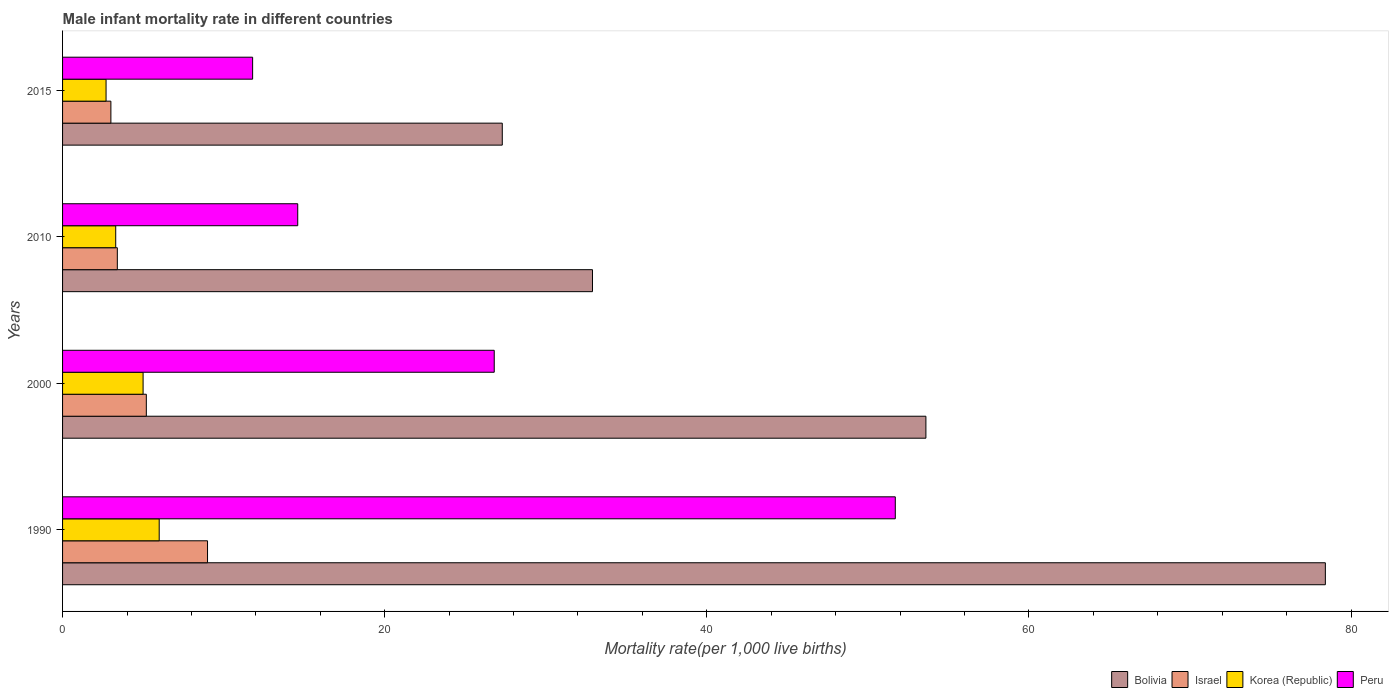How many groups of bars are there?
Keep it short and to the point. 4. Are the number of bars per tick equal to the number of legend labels?
Ensure brevity in your answer.  Yes. Are the number of bars on each tick of the Y-axis equal?
Give a very brief answer. Yes. How many bars are there on the 4th tick from the bottom?
Offer a terse response. 4. What is the male infant mortality rate in Peru in 1990?
Keep it short and to the point. 51.7. Across all years, what is the maximum male infant mortality rate in Bolivia?
Your answer should be very brief. 78.4. In which year was the male infant mortality rate in Israel maximum?
Your response must be concise. 1990. In which year was the male infant mortality rate in Israel minimum?
Make the answer very short. 2015. What is the total male infant mortality rate in Israel in the graph?
Make the answer very short. 20.6. What is the difference between the male infant mortality rate in Israel in 2000 and that in 2010?
Keep it short and to the point. 1.8. What is the difference between the male infant mortality rate in Korea (Republic) in 2010 and the male infant mortality rate in Israel in 2000?
Give a very brief answer. -1.9. What is the average male infant mortality rate in Korea (Republic) per year?
Make the answer very short. 4.25. In the year 1990, what is the difference between the male infant mortality rate in Korea (Republic) and male infant mortality rate in Peru?
Your response must be concise. -45.7. In how many years, is the male infant mortality rate in Israel greater than 32 ?
Make the answer very short. 0. What is the ratio of the male infant mortality rate in Peru in 2000 to that in 2010?
Provide a succinct answer. 1.84. Is the male infant mortality rate in Korea (Republic) in 1990 less than that in 2010?
Provide a succinct answer. No. Is the difference between the male infant mortality rate in Korea (Republic) in 1990 and 2015 greater than the difference between the male infant mortality rate in Peru in 1990 and 2015?
Provide a succinct answer. No. What is the difference between the highest and the second highest male infant mortality rate in Bolivia?
Ensure brevity in your answer.  24.8. In how many years, is the male infant mortality rate in Bolivia greater than the average male infant mortality rate in Bolivia taken over all years?
Provide a short and direct response. 2. Is the sum of the male infant mortality rate in Peru in 2000 and 2015 greater than the maximum male infant mortality rate in Bolivia across all years?
Offer a very short reply. No. What does the 3rd bar from the bottom in 2015 represents?
Give a very brief answer. Korea (Republic). Is it the case that in every year, the sum of the male infant mortality rate in Korea (Republic) and male infant mortality rate in Israel is greater than the male infant mortality rate in Bolivia?
Provide a succinct answer. No. Are all the bars in the graph horizontal?
Offer a very short reply. Yes. Does the graph contain any zero values?
Keep it short and to the point. No. Where does the legend appear in the graph?
Offer a terse response. Bottom right. What is the title of the graph?
Make the answer very short. Male infant mortality rate in different countries. What is the label or title of the X-axis?
Keep it short and to the point. Mortality rate(per 1,0 live births). What is the label or title of the Y-axis?
Make the answer very short. Years. What is the Mortality rate(per 1,000 live births) of Bolivia in 1990?
Provide a succinct answer. 78.4. What is the Mortality rate(per 1,000 live births) of Peru in 1990?
Keep it short and to the point. 51.7. What is the Mortality rate(per 1,000 live births) in Bolivia in 2000?
Your answer should be compact. 53.6. What is the Mortality rate(per 1,000 live births) in Korea (Republic) in 2000?
Offer a terse response. 5. What is the Mortality rate(per 1,000 live births) in Peru in 2000?
Your response must be concise. 26.8. What is the Mortality rate(per 1,000 live births) of Bolivia in 2010?
Provide a short and direct response. 32.9. What is the Mortality rate(per 1,000 live births) of Israel in 2010?
Provide a short and direct response. 3.4. What is the Mortality rate(per 1,000 live births) of Peru in 2010?
Your response must be concise. 14.6. What is the Mortality rate(per 1,000 live births) in Bolivia in 2015?
Your answer should be very brief. 27.3. What is the Mortality rate(per 1,000 live births) in Israel in 2015?
Your answer should be very brief. 3. What is the Mortality rate(per 1,000 live births) in Peru in 2015?
Ensure brevity in your answer.  11.8. Across all years, what is the maximum Mortality rate(per 1,000 live births) in Bolivia?
Provide a short and direct response. 78.4. Across all years, what is the maximum Mortality rate(per 1,000 live births) in Korea (Republic)?
Provide a succinct answer. 6. Across all years, what is the maximum Mortality rate(per 1,000 live births) in Peru?
Your response must be concise. 51.7. Across all years, what is the minimum Mortality rate(per 1,000 live births) in Bolivia?
Offer a terse response. 27.3. Across all years, what is the minimum Mortality rate(per 1,000 live births) of Israel?
Provide a succinct answer. 3. Across all years, what is the minimum Mortality rate(per 1,000 live births) in Korea (Republic)?
Your response must be concise. 2.7. What is the total Mortality rate(per 1,000 live births) of Bolivia in the graph?
Ensure brevity in your answer.  192.2. What is the total Mortality rate(per 1,000 live births) of Israel in the graph?
Your response must be concise. 20.6. What is the total Mortality rate(per 1,000 live births) of Peru in the graph?
Your answer should be very brief. 104.9. What is the difference between the Mortality rate(per 1,000 live births) in Bolivia in 1990 and that in 2000?
Your answer should be compact. 24.8. What is the difference between the Mortality rate(per 1,000 live births) of Peru in 1990 and that in 2000?
Your answer should be very brief. 24.9. What is the difference between the Mortality rate(per 1,000 live births) of Bolivia in 1990 and that in 2010?
Ensure brevity in your answer.  45.5. What is the difference between the Mortality rate(per 1,000 live births) in Israel in 1990 and that in 2010?
Offer a very short reply. 5.6. What is the difference between the Mortality rate(per 1,000 live births) of Peru in 1990 and that in 2010?
Offer a very short reply. 37.1. What is the difference between the Mortality rate(per 1,000 live births) in Bolivia in 1990 and that in 2015?
Provide a short and direct response. 51.1. What is the difference between the Mortality rate(per 1,000 live births) of Peru in 1990 and that in 2015?
Provide a short and direct response. 39.9. What is the difference between the Mortality rate(per 1,000 live births) of Bolivia in 2000 and that in 2010?
Keep it short and to the point. 20.7. What is the difference between the Mortality rate(per 1,000 live births) of Korea (Republic) in 2000 and that in 2010?
Provide a short and direct response. 1.7. What is the difference between the Mortality rate(per 1,000 live births) of Peru in 2000 and that in 2010?
Give a very brief answer. 12.2. What is the difference between the Mortality rate(per 1,000 live births) of Bolivia in 2000 and that in 2015?
Offer a very short reply. 26.3. What is the difference between the Mortality rate(per 1,000 live births) in Israel in 2000 and that in 2015?
Your answer should be very brief. 2.2. What is the difference between the Mortality rate(per 1,000 live births) of Korea (Republic) in 2000 and that in 2015?
Make the answer very short. 2.3. What is the difference between the Mortality rate(per 1,000 live births) of Peru in 2000 and that in 2015?
Ensure brevity in your answer.  15. What is the difference between the Mortality rate(per 1,000 live births) of Israel in 2010 and that in 2015?
Your response must be concise. 0.4. What is the difference between the Mortality rate(per 1,000 live births) in Peru in 2010 and that in 2015?
Offer a very short reply. 2.8. What is the difference between the Mortality rate(per 1,000 live births) of Bolivia in 1990 and the Mortality rate(per 1,000 live births) of Israel in 2000?
Provide a short and direct response. 73.2. What is the difference between the Mortality rate(per 1,000 live births) in Bolivia in 1990 and the Mortality rate(per 1,000 live births) in Korea (Republic) in 2000?
Your answer should be compact. 73.4. What is the difference between the Mortality rate(per 1,000 live births) of Bolivia in 1990 and the Mortality rate(per 1,000 live births) of Peru in 2000?
Offer a terse response. 51.6. What is the difference between the Mortality rate(per 1,000 live births) of Israel in 1990 and the Mortality rate(per 1,000 live births) of Korea (Republic) in 2000?
Make the answer very short. 4. What is the difference between the Mortality rate(per 1,000 live births) of Israel in 1990 and the Mortality rate(per 1,000 live births) of Peru in 2000?
Your response must be concise. -17.8. What is the difference between the Mortality rate(per 1,000 live births) in Korea (Republic) in 1990 and the Mortality rate(per 1,000 live births) in Peru in 2000?
Keep it short and to the point. -20.8. What is the difference between the Mortality rate(per 1,000 live births) of Bolivia in 1990 and the Mortality rate(per 1,000 live births) of Korea (Republic) in 2010?
Offer a terse response. 75.1. What is the difference between the Mortality rate(per 1,000 live births) of Bolivia in 1990 and the Mortality rate(per 1,000 live births) of Peru in 2010?
Your response must be concise. 63.8. What is the difference between the Mortality rate(per 1,000 live births) of Israel in 1990 and the Mortality rate(per 1,000 live births) of Korea (Republic) in 2010?
Offer a very short reply. 5.7. What is the difference between the Mortality rate(per 1,000 live births) in Israel in 1990 and the Mortality rate(per 1,000 live births) in Peru in 2010?
Keep it short and to the point. -5.6. What is the difference between the Mortality rate(per 1,000 live births) in Bolivia in 1990 and the Mortality rate(per 1,000 live births) in Israel in 2015?
Keep it short and to the point. 75.4. What is the difference between the Mortality rate(per 1,000 live births) of Bolivia in 1990 and the Mortality rate(per 1,000 live births) of Korea (Republic) in 2015?
Provide a succinct answer. 75.7. What is the difference between the Mortality rate(per 1,000 live births) in Bolivia in 1990 and the Mortality rate(per 1,000 live births) in Peru in 2015?
Provide a succinct answer. 66.6. What is the difference between the Mortality rate(per 1,000 live births) in Israel in 1990 and the Mortality rate(per 1,000 live births) in Korea (Republic) in 2015?
Give a very brief answer. 6.3. What is the difference between the Mortality rate(per 1,000 live births) in Korea (Republic) in 1990 and the Mortality rate(per 1,000 live births) in Peru in 2015?
Give a very brief answer. -5.8. What is the difference between the Mortality rate(per 1,000 live births) in Bolivia in 2000 and the Mortality rate(per 1,000 live births) in Israel in 2010?
Offer a terse response. 50.2. What is the difference between the Mortality rate(per 1,000 live births) in Bolivia in 2000 and the Mortality rate(per 1,000 live births) in Korea (Republic) in 2010?
Give a very brief answer. 50.3. What is the difference between the Mortality rate(per 1,000 live births) in Bolivia in 2000 and the Mortality rate(per 1,000 live births) in Peru in 2010?
Keep it short and to the point. 39. What is the difference between the Mortality rate(per 1,000 live births) of Israel in 2000 and the Mortality rate(per 1,000 live births) of Korea (Republic) in 2010?
Your response must be concise. 1.9. What is the difference between the Mortality rate(per 1,000 live births) of Israel in 2000 and the Mortality rate(per 1,000 live births) of Peru in 2010?
Make the answer very short. -9.4. What is the difference between the Mortality rate(per 1,000 live births) in Bolivia in 2000 and the Mortality rate(per 1,000 live births) in Israel in 2015?
Make the answer very short. 50.6. What is the difference between the Mortality rate(per 1,000 live births) in Bolivia in 2000 and the Mortality rate(per 1,000 live births) in Korea (Republic) in 2015?
Your answer should be very brief. 50.9. What is the difference between the Mortality rate(per 1,000 live births) in Bolivia in 2000 and the Mortality rate(per 1,000 live births) in Peru in 2015?
Your answer should be very brief. 41.8. What is the difference between the Mortality rate(per 1,000 live births) in Israel in 2000 and the Mortality rate(per 1,000 live births) in Korea (Republic) in 2015?
Give a very brief answer. 2.5. What is the difference between the Mortality rate(per 1,000 live births) of Bolivia in 2010 and the Mortality rate(per 1,000 live births) of Israel in 2015?
Give a very brief answer. 29.9. What is the difference between the Mortality rate(per 1,000 live births) of Bolivia in 2010 and the Mortality rate(per 1,000 live births) of Korea (Republic) in 2015?
Provide a short and direct response. 30.2. What is the difference between the Mortality rate(per 1,000 live births) of Bolivia in 2010 and the Mortality rate(per 1,000 live births) of Peru in 2015?
Your answer should be very brief. 21.1. What is the difference between the Mortality rate(per 1,000 live births) of Israel in 2010 and the Mortality rate(per 1,000 live births) of Korea (Republic) in 2015?
Provide a succinct answer. 0.7. What is the average Mortality rate(per 1,000 live births) of Bolivia per year?
Offer a very short reply. 48.05. What is the average Mortality rate(per 1,000 live births) in Israel per year?
Your response must be concise. 5.15. What is the average Mortality rate(per 1,000 live births) of Korea (Republic) per year?
Offer a terse response. 4.25. What is the average Mortality rate(per 1,000 live births) of Peru per year?
Provide a succinct answer. 26.23. In the year 1990, what is the difference between the Mortality rate(per 1,000 live births) of Bolivia and Mortality rate(per 1,000 live births) of Israel?
Give a very brief answer. 69.4. In the year 1990, what is the difference between the Mortality rate(per 1,000 live births) in Bolivia and Mortality rate(per 1,000 live births) in Korea (Republic)?
Keep it short and to the point. 72.4. In the year 1990, what is the difference between the Mortality rate(per 1,000 live births) of Bolivia and Mortality rate(per 1,000 live births) of Peru?
Give a very brief answer. 26.7. In the year 1990, what is the difference between the Mortality rate(per 1,000 live births) in Israel and Mortality rate(per 1,000 live births) in Korea (Republic)?
Keep it short and to the point. 3. In the year 1990, what is the difference between the Mortality rate(per 1,000 live births) of Israel and Mortality rate(per 1,000 live births) of Peru?
Provide a succinct answer. -42.7. In the year 1990, what is the difference between the Mortality rate(per 1,000 live births) of Korea (Republic) and Mortality rate(per 1,000 live births) of Peru?
Your answer should be very brief. -45.7. In the year 2000, what is the difference between the Mortality rate(per 1,000 live births) in Bolivia and Mortality rate(per 1,000 live births) in Israel?
Your answer should be very brief. 48.4. In the year 2000, what is the difference between the Mortality rate(per 1,000 live births) in Bolivia and Mortality rate(per 1,000 live births) in Korea (Republic)?
Provide a short and direct response. 48.6. In the year 2000, what is the difference between the Mortality rate(per 1,000 live births) of Bolivia and Mortality rate(per 1,000 live births) of Peru?
Your response must be concise. 26.8. In the year 2000, what is the difference between the Mortality rate(per 1,000 live births) of Israel and Mortality rate(per 1,000 live births) of Peru?
Provide a short and direct response. -21.6. In the year 2000, what is the difference between the Mortality rate(per 1,000 live births) of Korea (Republic) and Mortality rate(per 1,000 live births) of Peru?
Keep it short and to the point. -21.8. In the year 2010, what is the difference between the Mortality rate(per 1,000 live births) of Bolivia and Mortality rate(per 1,000 live births) of Israel?
Offer a terse response. 29.5. In the year 2010, what is the difference between the Mortality rate(per 1,000 live births) of Bolivia and Mortality rate(per 1,000 live births) of Korea (Republic)?
Keep it short and to the point. 29.6. In the year 2010, what is the difference between the Mortality rate(per 1,000 live births) of Bolivia and Mortality rate(per 1,000 live births) of Peru?
Provide a succinct answer. 18.3. In the year 2010, what is the difference between the Mortality rate(per 1,000 live births) of Israel and Mortality rate(per 1,000 live births) of Korea (Republic)?
Your answer should be compact. 0.1. In the year 2010, what is the difference between the Mortality rate(per 1,000 live births) in Israel and Mortality rate(per 1,000 live births) in Peru?
Offer a very short reply. -11.2. In the year 2015, what is the difference between the Mortality rate(per 1,000 live births) of Bolivia and Mortality rate(per 1,000 live births) of Israel?
Offer a terse response. 24.3. In the year 2015, what is the difference between the Mortality rate(per 1,000 live births) in Bolivia and Mortality rate(per 1,000 live births) in Korea (Republic)?
Give a very brief answer. 24.6. What is the ratio of the Mortality rate(per 1,000 live births) in Bolivia in 1990 to that in 2000?
Provide a succinct answer. 1.46. What is the ratio of the Mortality rate(per 1,000 live births) in Israel in 1990 to that in 2000?
Your answer should be very brief. 1.73. What is the ratio of the Mortality rate(per 1,000 live births) in Korea (Republic) in 1990 to that in 2000?
Ensure brevity in your answer.  1.2. What is the ratio of the Mortality rate(per 1,000 live births) of Peru in 1990 to that in 2000?
Your answer should be compact. 1.93. What is the ratio of the Mortality rate(per 1,000 live births) in Bolivia in 1990 to that in 2010?
Offer a terse response. 2.38. What is the ratio of the Mortality rate(per 1,000 live births) in Israel in 1990 to that in 2010?
Make the answer very short. 2.65. What is the ratio of the Mortality rate(per 1,000 live births) of Korea (Republic) in 1990 to that in 2010?
Your answer should be compact. 1.82. What is the ratio of the Mortality rate(per 1,000 live births) in Peru in 1990 to that in 2010?
Make the answer very short. 3.54. What is the ratio of the Mortality rate(per 1,000 live births) of Bolivia in 1990 to that in 2015?
Offer a terse response. 2.87. What is the ratio of the Mortality rate(per 1,000 live births) in Korea (Republic) in 1990 to that in 2015?
Your answer should be compact. 2.22. What is the ratio of the Mortality rate(per 1,000 live births) in Peru in 1990 to that in 2015?
Offer a terse response. 4.38. What is the ratio of the Mortality rate(per 1,000 live births) in Bolivia in 2000 to that in 2010?
Your answer should be very brief. 1.63. What is the ratio of the Mortality rate(per 1,000 live births) of Israel in 2000 to that in 2010?
Your answer should be very brief. 1.53. What is the ratio of the Mortality rate(per 1,000 live births) of Korea (Republic) in 2000 to that in 2010?
Your answer should be very brief. 1.52. What is the ratio of the Mortality rate(per 1,000 live births) in Peru in 2000 to that in 2010?
Your answer should be compact. 1.84. What is the ratio of the Mortality rate(per 1,000 live births) of Bolivia in 2000 to that in 2015?
Provide a succinct answer. 1.96. What is the ratio of the Mortality rate(per 1,000 live births) in Israel in 2000 to that in 2015?
Give a very brief answer. 1.73. What is the ratio of the Mortality rate(per 1,000 live births) of Korea (Republic) in 2000 to that in 2015?
Ensure brevity in your answer.  1.85. What is the ratio of the Mortality rate(per 1,000 live births) of Peru in 2000 to that in 2015?
Your response must be concise. 2.27. What is the ratio of the Mortality rate(per 1,000 live births) in Bolivia in 2010 to that in 2015?
Give a very brief answer. 1.21. What is the ratio of the Mortality rate(per 1,000 live births) of Israel in 2010 to that in 2015?
Give a very brief answer. 1.13. What is the ratio of the Mortality rate(per 1,000 live births) in Korea (Republic) in 2010 to that in 2015?
Ensure brevity in your answer.  1.22. What is the ratio of the Mortality rate(per 1,000 live births) in Peru in 2010 to that in 2015?
Provide a short and direct response. 1.24. What is the difference between the highest and the second highest Mortality rate(per 1,000 live births) in Bolivia?
Your response must be concise. 24.8. What is the difference between the highest and the second highest Mortality rate(per 1,000 live births) in Israel?
Your answer should be compact. 3.8. What is the difference between the highest and the second highest Mortality rate(per 1,000 live births) in Peru?
Provide a short and direct response. 24.9. What is the difference between the highest and the lowest Mortality rate(per 1,000 live births) of Bolivia?
Keep it short and to the point. 51.1. What is the difference between the highest and the lowest Mortality rate(per 1,000 live births) in Korea (Republic)?
Make the answer very short. 3.3. What is the difference between the highest and the lowest Mortality rate(per 1,000 live births) in Peru?
Your response must be concise. 39.9. 